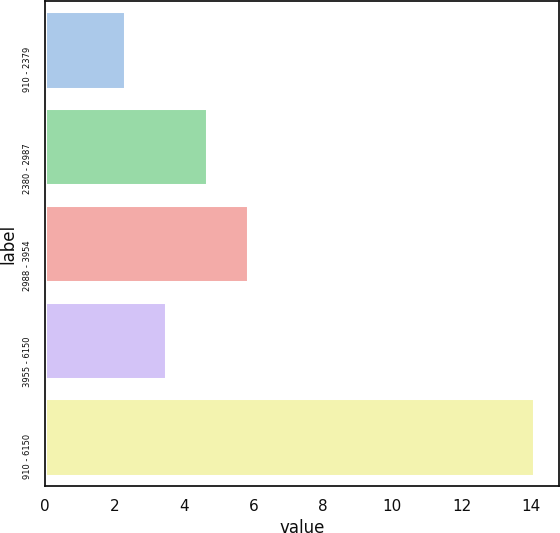Convert chart to OTSL. <chart><loc_0><loc_0><loc_500><loc_500><bar_chart><fcel>910 - 2379<fcel>2380 - 2987<fcel>2988 - 3954<fcel>3955 - 6150<fcel>910 - 6150<nl><fcel>2.3<fcel>4.66<fcel>5.84<fcel>3.48<fcel>14.1<nl></chart> 